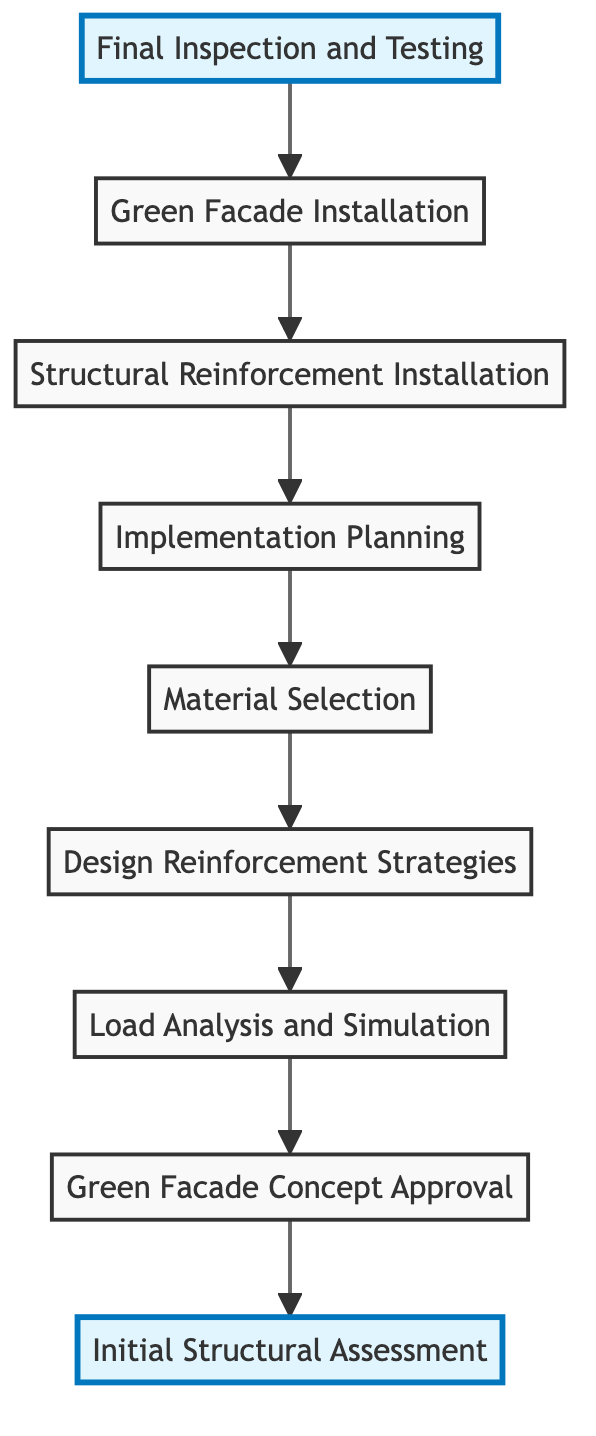What is the first step in the flow? The first step in the flow is depicted at the bottom of the diagram as 'Initial Structural Assessment'. It has no dependencies, meaning it’s the starting point of the process.
Answer: Initial Structural Assessment How many total steps are in this diagram? By counting the nodes in the diagram, we identify 9 distinct steps, with each step representing a part of the process leading to the final goal.
Answer: 9 What is the dependency of 'Load Analysis and Simulation'? 'Load Analysis and Simulation' depends on 'Green Facade Concept Approval', meaning this step can only occur after approval has been secured.
Answer: Green Facade Concept Approval What steps are involved in the final phase before testing? Before 'Final Inspection and Testing', 'Green Facade Installation' and 'Structural Reinforcement Installation' are the preceding steps in the flow, necessary for preparing for testing.
Answer: Green Facade Installation, Structural Reinforcement Installation Which step requires material selection? 'Material Selection' is explicitly indicated as a step that follows 'Design Reinforcement Strategies', relying on the designs made in the previous step.
Answer: Design Reinforcement Strategies What is the last step in the diagram? The last step in the process, situated at the top of the flow chart, is 'Final Inspection and Testing', which concludes the outlined procedure.
Answer: Final Inspection and Testing How many steps depend on 'Implementation Planning'? Only one step, 'Structural Reinforcement Installation', depends on 'Implementation Planning', indicating a direct relationship in the execution order.
Answer: 1 What is the purpose of 'Design Reinforcement Strategies'? The purpose of 'Design Reinforcement Strategies' is to create structural reinforcements that can adequately support the additional load from the green facade.
Answer: Support additional loads What comes after 'Green Facade Installation'? Following 'Green Facade Installation', the next and final step in the flow is 'Final Inspection and Testing', marking the completion of the installation phase.
Answer: Final Inspection and Testing 